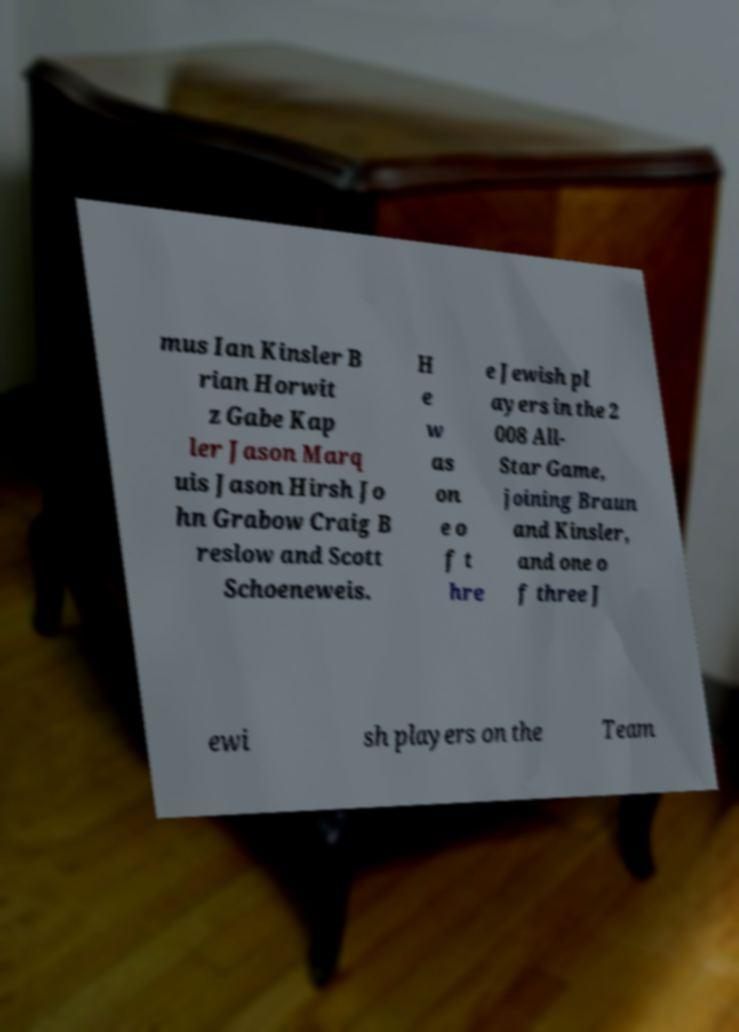Please read and relay the text visible in this image. What does it say? mus Ian Kinsler B rian Horwit z Gabe Kap ler Jason Marq uis Jason Hirsh Jo hn Grabow Craig B reslow and Scott Schoeneweis. H e w as on e o f t hre e Jewish pl ayers in the 2 008 All- Star Game, joining Braun and Kinsler, and one o f three J ewi sh players on the Team 